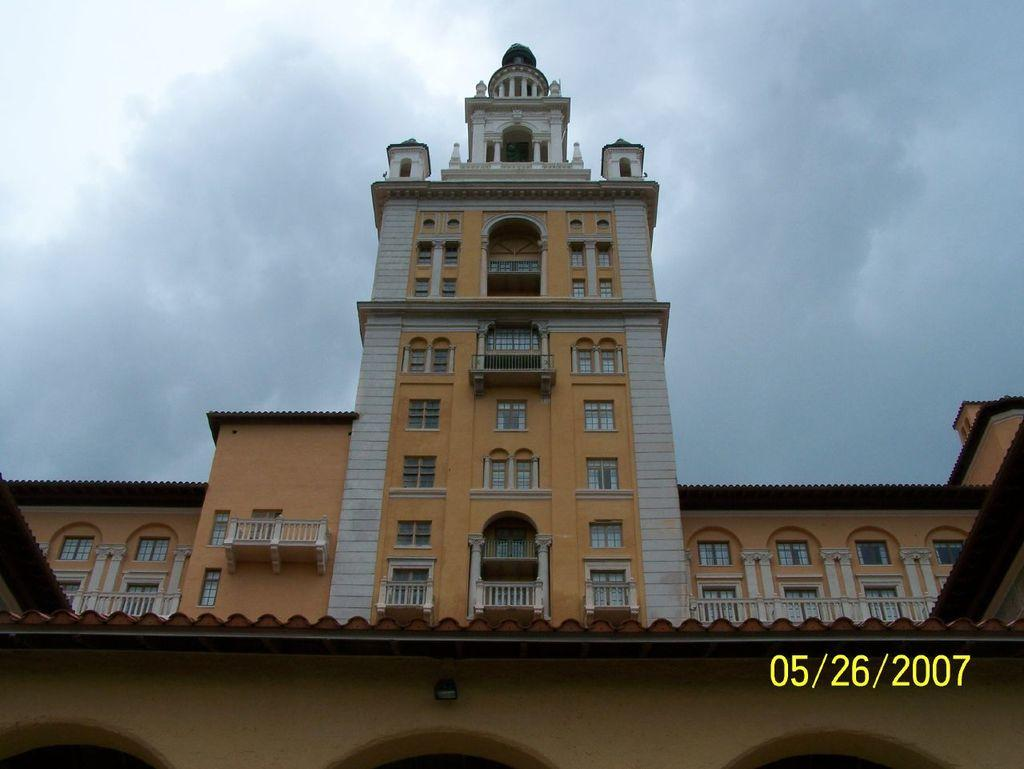What is the main structure in the image? There is a building in the image. What can be seen in the background of the image? The sky is visible in the background of the image. How would you describe the sky in the image? The sky appears to be cloudy. Is there any additional information or marking on the image? Yes, there is a watermark on the bottom right side of the image. Are there any clams visible on the building in the image? No, there are no clams visible on the building in the image. 